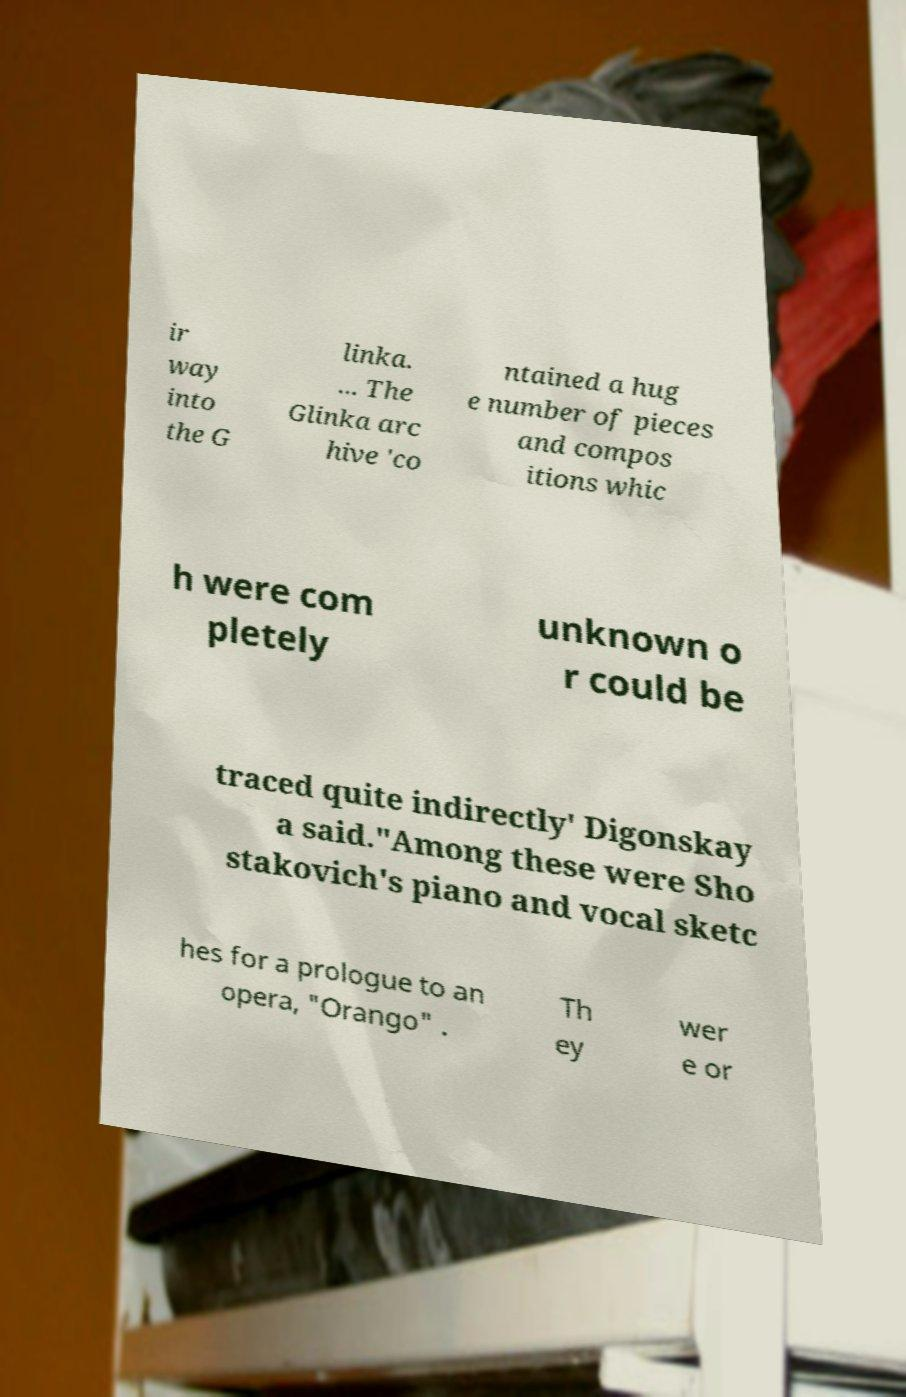What messages or text are displayed in this image? I need them in a readable, typed format. ir way into the G linka. ... The Glinka arc hive 'co ntained a hug e number of pieces and compos itions whic h were com pletely unknown o r could be traced quite indirectly' Digonskay a said."Among these were Sho stakovich's piano and vocal sketc hes for a prologue to an opera, "Orango" . Th ey wer e or 